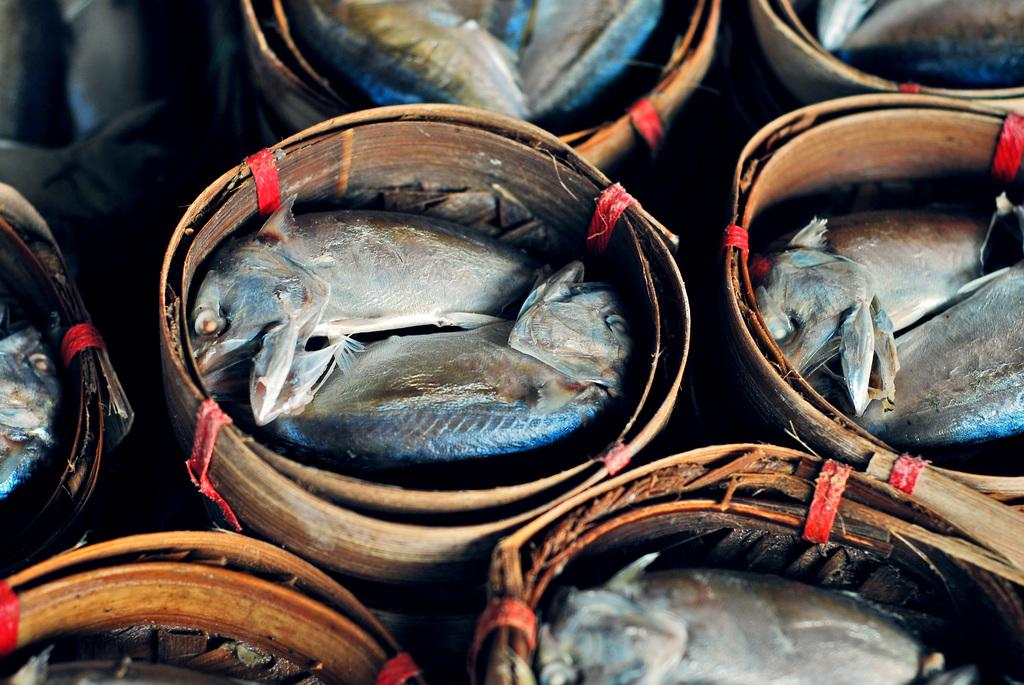What objects are present in the picture? There are buckets in the picture. What is inside the buckets? There are fishes in the buckets. What type of glue is being used to hold the coast together in the image? There is no coast or glue present in the image; it features buckets with fishes inside. 